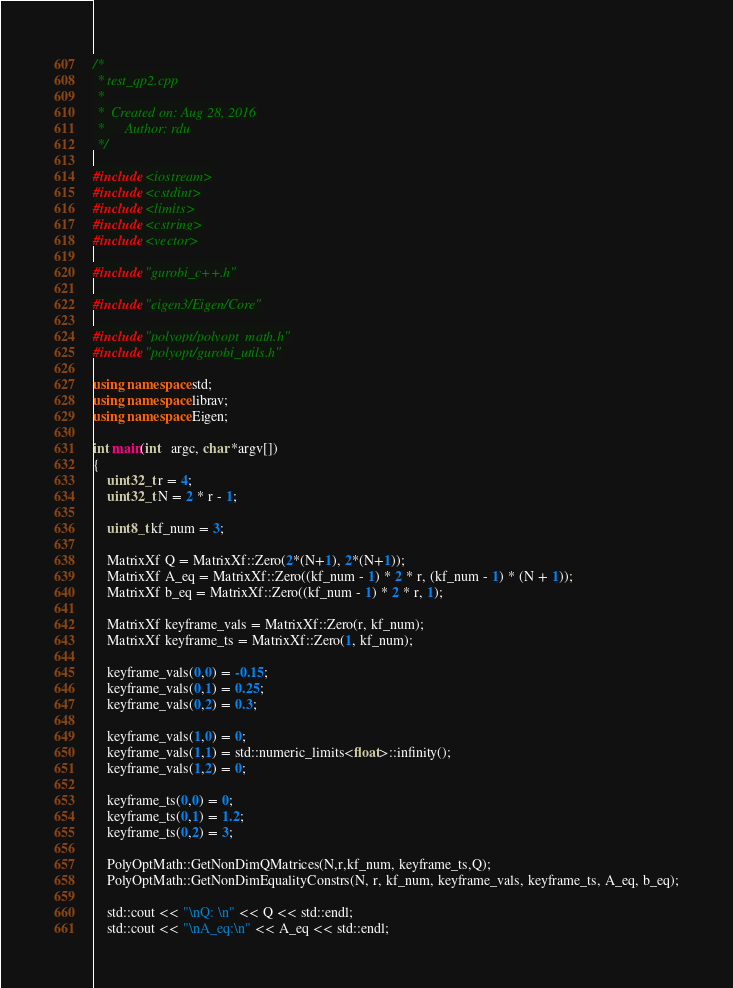Convert code to text. <code><loc_0><loc_0><loc_500><loc_500><_C++_>/*
 * test_qp2.cpp
 *
 *  Created on: Aug 28, 2016
 *      Author: rdu
 */

#include <iostream>
#include <cstdint>
#include <limits>
#include <cstring>
#include <vector>

#include "gurobi_c++.h"

#include "eigen3/Eigen/Core"

#include "polyopt/polyopt_math.h"
#include "polyopt/gurobi_utils.h"

using namespace std;
using namespace librav;
using namespace Eigen;

int main(int   argc, char *argv[])
{
	uint32_t r = 4;
	uint32_t N = 2 * r - 1;

	uint8_t kf_num = 3;

	MatrixXf Q = MatrixXf::Zero(2*(N+1), 2*(N+1));
	MatrixXf A_eq = MatrixXf::Zero((kf_num - 1) * 2 * r, (kf_num - 1) * (N + 1));
	MatrixXf b_eq = MatrixXf::Zero((kf_num - 1) * 2 * r, 1);

	MatrixXf keyframe_vals = MatrixXf::Zero(r, kf_num);
	MatrixXf keyframe_ts = MatrixXf::Zero(1, kf_num);

	keyframe_vals(0,0) = -0.15;
	keyframe_vals(0,1) = 0.25;
	keyframe_vals(0,2) = 0.3;

	keyframe_vals(1,0) = 0;
	keyframe_vals(1,1) = std::numeric_limits<float>::infinity();
	keyframe_vals(1,2) = 0;

	keyframe_ts(0,0) = 0;
	keyframe_ts(0,1) = 1.2;
	keyframe_ts(0,2) = 3;

	PolyOptMath::GetNonDimQMatrices(N,r,kf_num, keyframe_ts,Q);
	PolyOptMath::GetNonDimEqualityConstrs(N, r, kf_num, keyframe_vals, keyframe_ts, A_eq, b_eq);

	std::cout << "\nQ: \n" << Q << std::endl;
	std::cout << "\nA_eq:\n" << A_eq << std::endl;</code> 